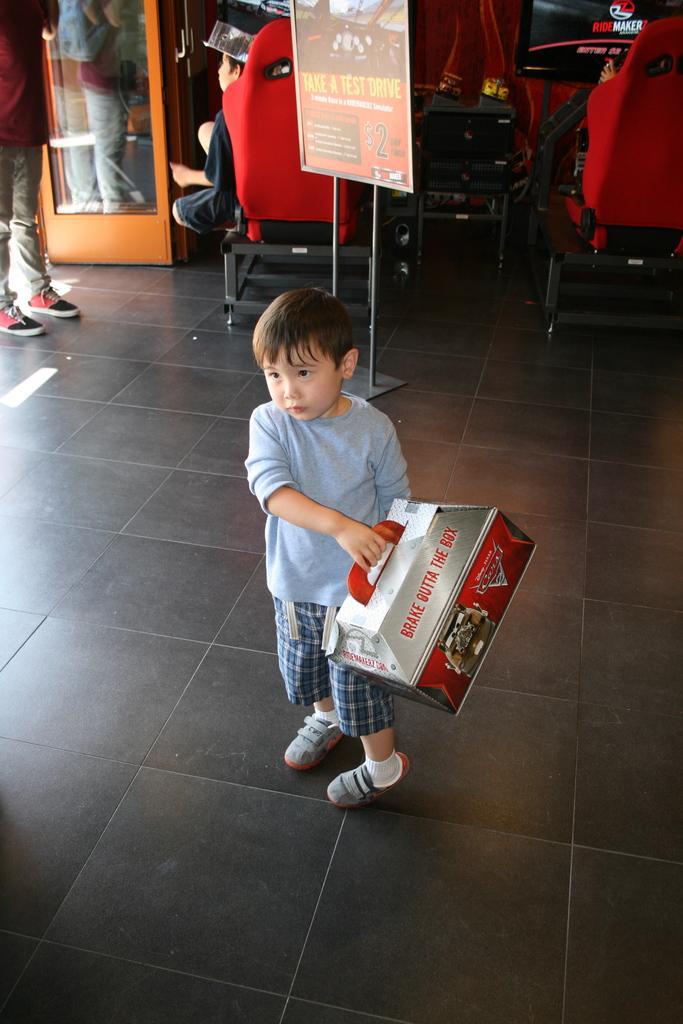In one or two sentences, can you explain what this image depicts? In the image there is a boy standing on the floor and holding some object, behind him there are two chairs and two kids are playing some video games by sitting on the chairs, on the left side there is a man and behind the man there is a door. 